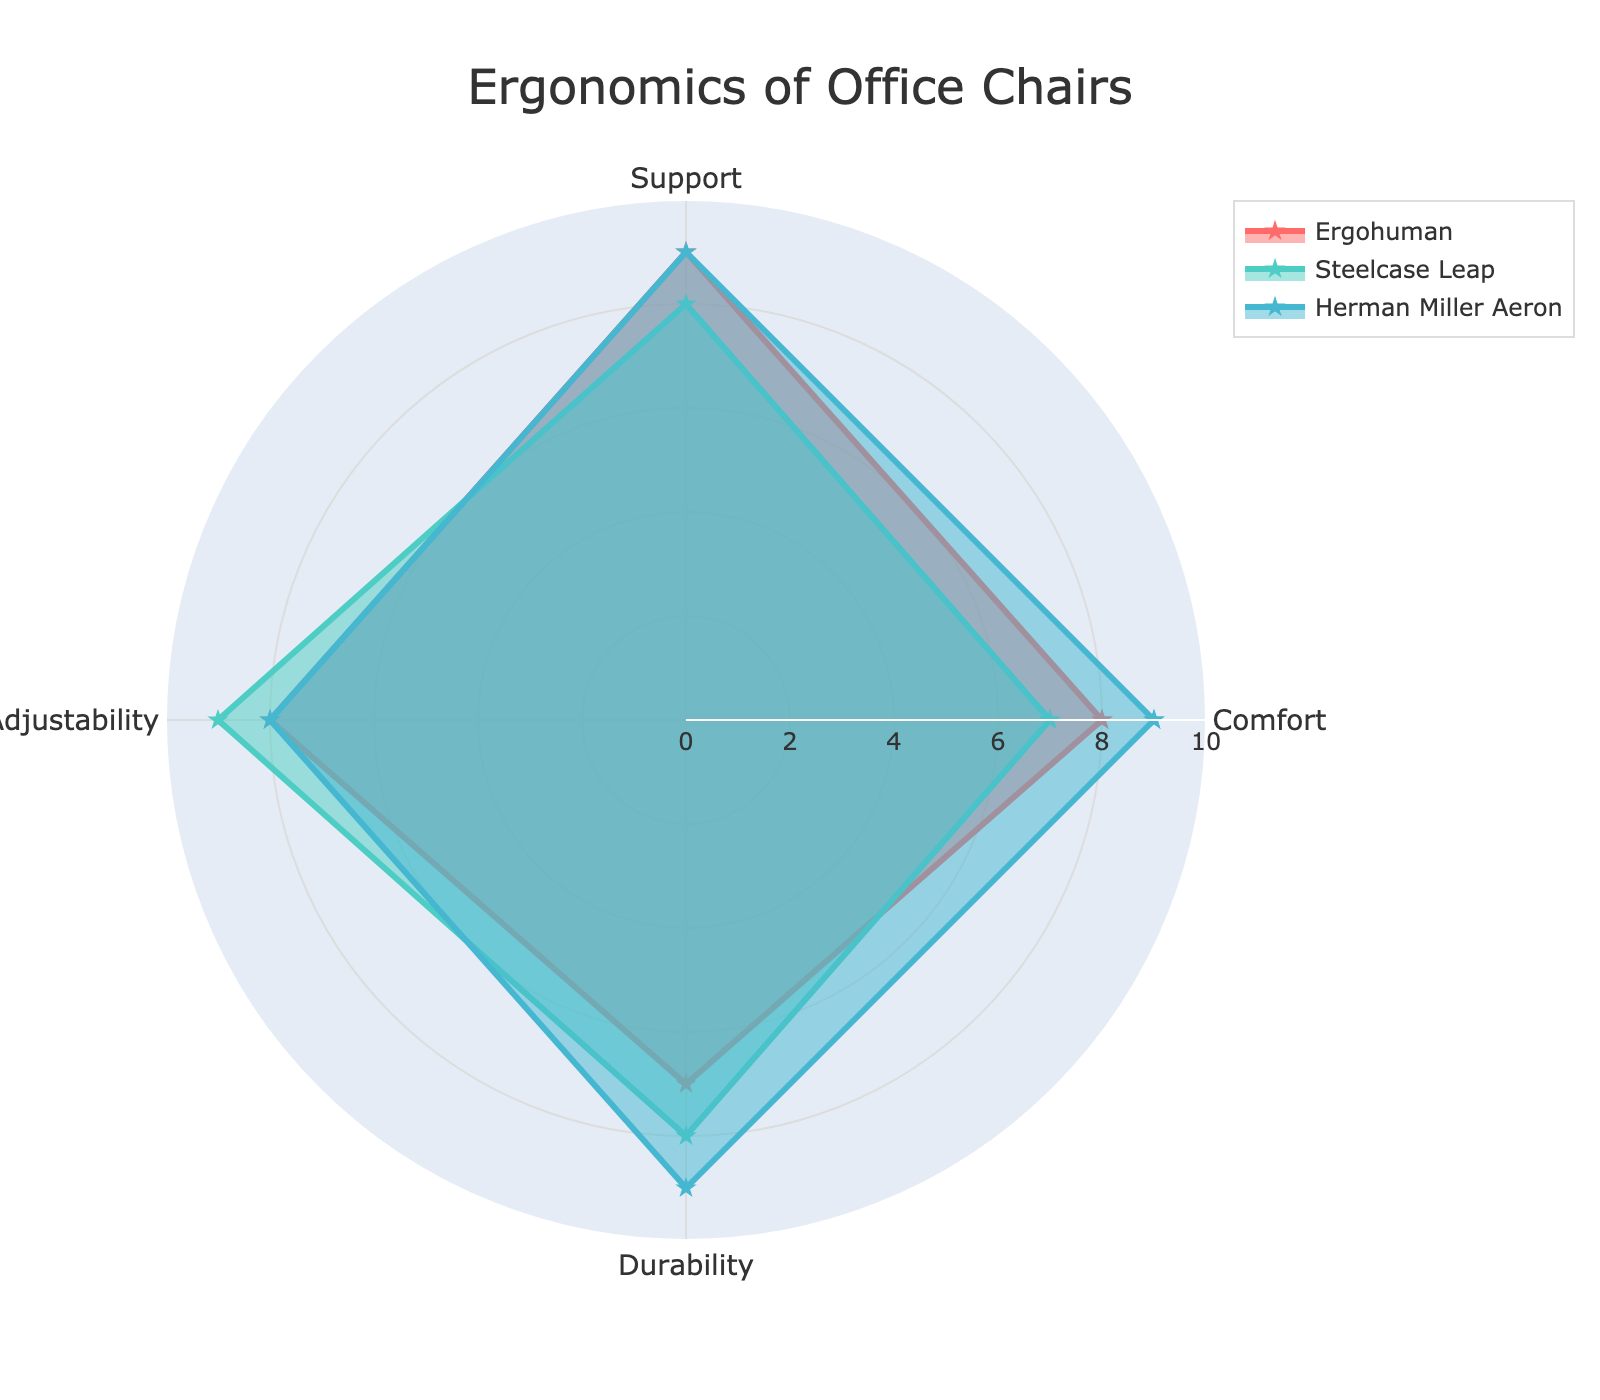What's the title of the chart? The title is usually prominently displayed near the top center of the figure.
Answer: Ergonomics of Office Chairs Which chair scores the highest in Comfort? Looking at the Comfort category, you can see which line reaches the highest point on the radial axis.
Answer: Herman Miller Aeron Out of the four categories, which chair has the most consistent ratings? By observing the figure, the most consistent chair will have lines that form a shape evenly spaced around the center with minimal variation.
Answer: Herman Miller Aeron How does the Steelcase Leap compare to the Ergohuman in Support? Find the values of Support for both Steelcase Leap and Ergohuman, then compare them. The figure's radial lines help in directly reading the values from the categories.
Answer: Steelcase Leap: 8, Ergohuman: 9. Ergohuman has better support Which chair needs improvement in Durability? The chair with the lowest Durability rating will show the smallest extension from the center in that category.
Answer: Ergohuman What is the average score of the Ergohuman chair across all categories? Sum the values for Ergohuman across all categories and divide by the number of categories. (Comfort: 8, Support: 9, Adjustability: 8, Durability: 7). Calculation: (8+9+8+7)/4 = 8
Answer: 8 Which category shows the greatest range of values among the chairs? Look at the radial spread for each category. The one with the widest range from lowest to highest value has the greatest variation.
Answer: Durability In which category does the Steelcase Leap outperform the other chairs? Compare the Steelcase Leap values with others for each category, identifying where it has the highest value or is equal to the top value.
Answer: Adjustability What are the combined scores of Comfort and Support for the Herman Miller Aeron? Sum the Comfort and Support values for Herman Miller Aeron. Calculation: Comfort (9) + Support (9) = 18.
Answer: 18 If you average the Adjustability scores of all three chairs, what is the resulting value? Sum the Adjustability values for each chair and divide by the number of chairs. (Ergohuman: 8, Steelcase Leap: 9, Herman Miller Aeron: 8). Calculation: (8+9+8)/3 = 8.33
Answer: 8.33 